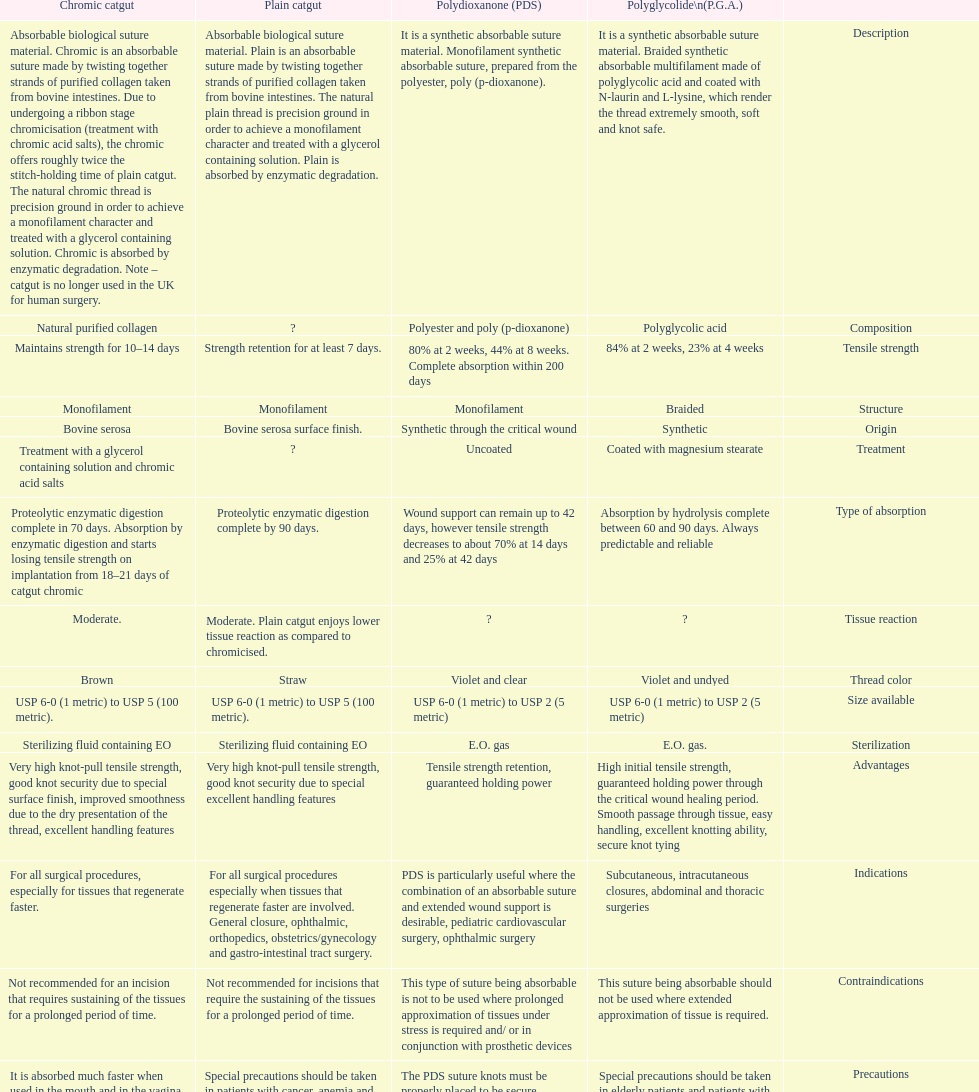Which suture can remain to at most 42 days Polydioxanone (PDS). 